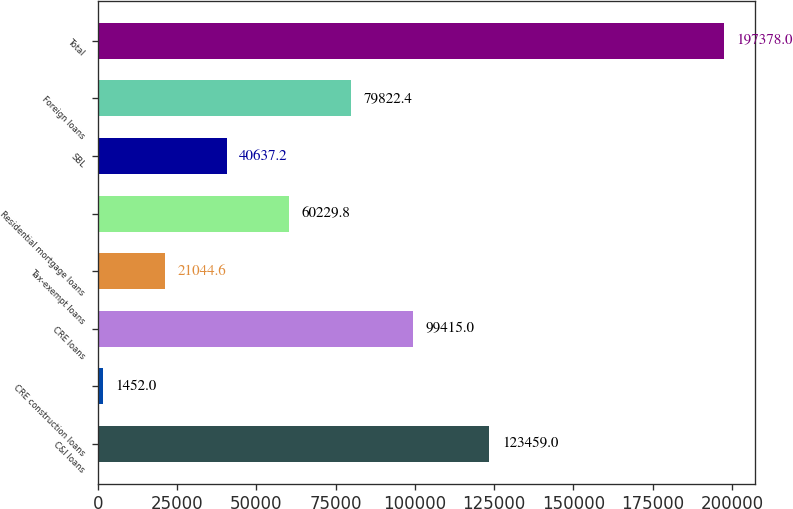Convert chart. <chart><loc_0><loc_0><loc_500><loc_500><bar_chart><fcel>C&I loans<fcel>CRE construction loans<fcel>CRE loans<fcel>Tax-exempt loans<fcel>Residential mortgage loans<fcel>SBL<fcel>Foreign loans<fcel>Total<nl><fcel>123459<fcel>1452<fcel>99415<fcel>21044.6<fcel>60229.8<fcel>40637.2<fcel>79822.4<fcel>197378<nl></chart> 